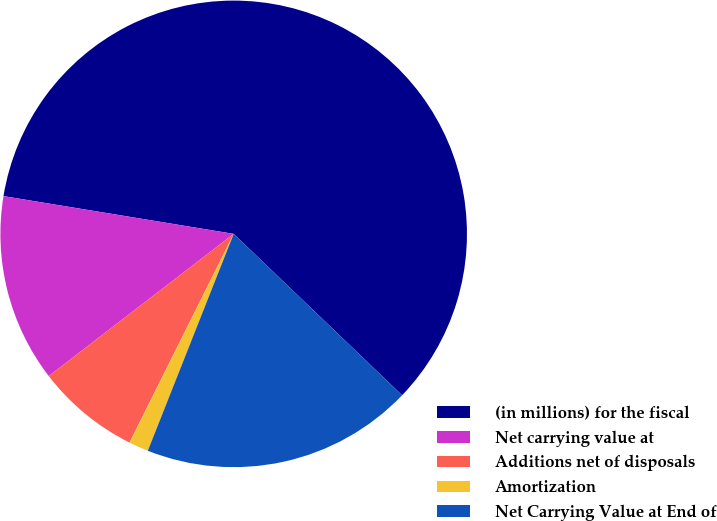Convert chart. <chart><loc_0><loc_0><loc_500><loc_500><pie_chart><fcel>(in millions) for the fiscal<fcel>Net carrying value at<fcel>Additions net of disposals<fcel>Amortization<fcel>Net Carrying Value at End of<nl><fcel>59.58%<fcel>13.02%<fcel>7.2%<fcel>1.37%<fcel>18.84%<nl></chart> 